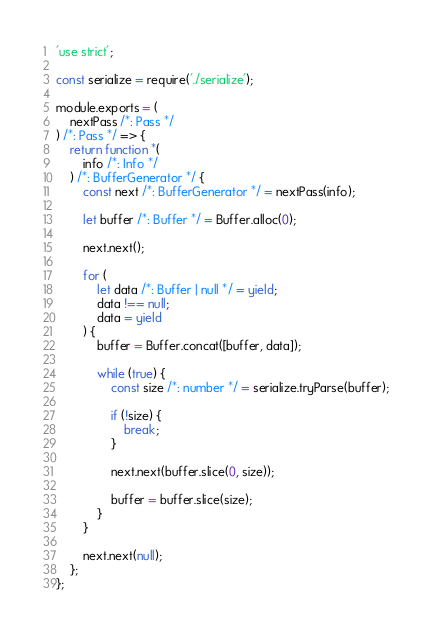<code> <loc_0><loc_0><loc_500><loc_500><_JavaScript_>'use strict';

const serialize = require('./serialize');

module.exports = (
    nextPass /*: Pass */
) /*: Pass */ => {
    return function *(
        info /*: Info */
    ) /*: BufferGenerator */ {
        const next /*: BufferGenerator */ = nextPass(info);

        let buffer /*: Buffer */ = Buffer.alloc(0);

        next.next();

        for (
            let data /*: Buffer | null */ = yield;
            data !== null;
            data = yield
        ) {
            buffer = Buffer.concat([buffer, data]);

            while (true) {
                const size /*: number */ = serialize.tryParse(buffer);

                if (!size) {
                    break;
                }

                next.next(buffer.slice(0, size));

                buffer = buffer.slice(size);
            }
        }

        next.next(null);
    };
};
</code> 